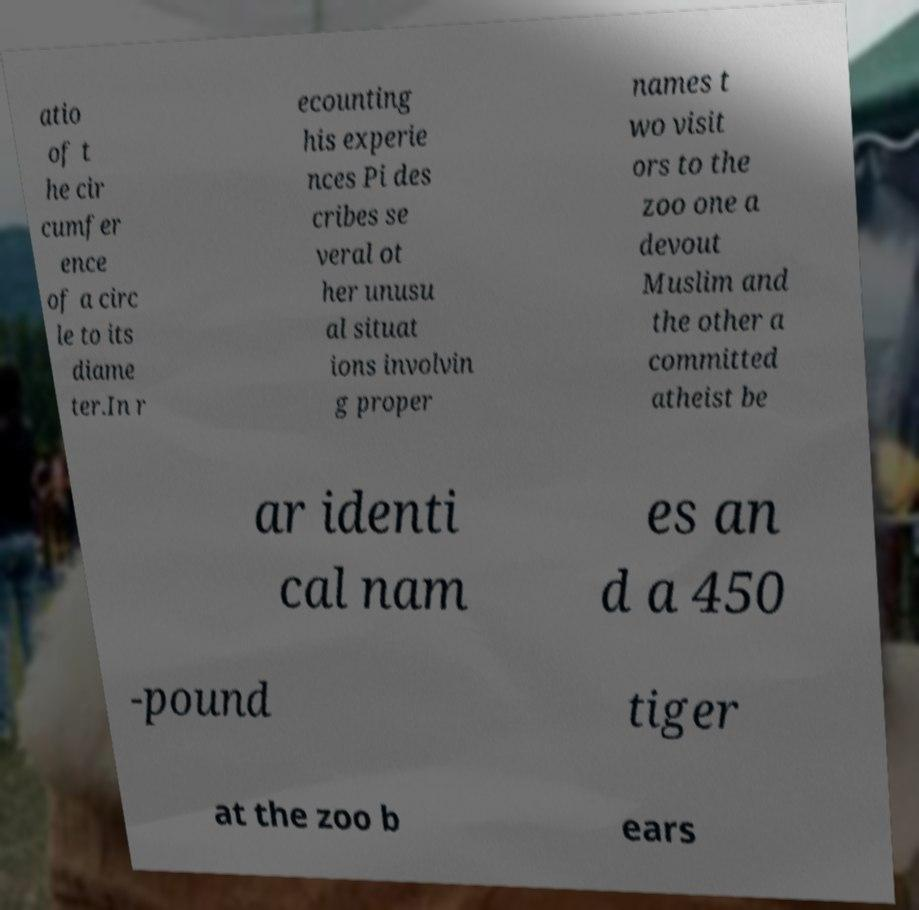What messages or text are displayed in this image? I need them in a readable, typed format. atio of t he cir cumfer ence of a circ le to its diame ter.In r ecounting his experie nces Pi des cribes se veral ot her unusu al situat ions involvin g proper names t wo visit ors to the zoo one a devout Muslim and the other a committed atheist be ar identi cal nam es an d a 450 -pound tiger at the zoo b ears 